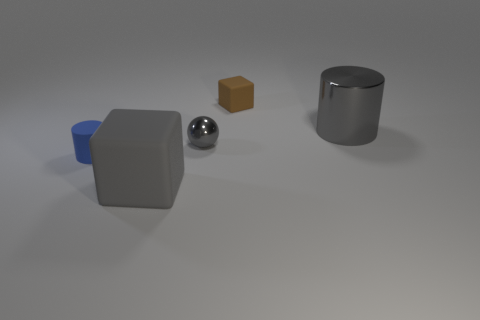There is a thing on the right side of the rubber block behind the big gray shiny object; is there a small cylinder in front of it?
Keep it short and to the point. Yes. There is a gray object that is to the left of the large metal object and behind the large gray rubber object; how big is it?
Your answer should be very brief. Small. What number of other gray cylinders have the same material as the gray cylinder?
Offer a terse response. 0. What number of cubes are tiny matte things or tiny objects?
Your answer should be very brief. 1. Is the number of matte things the same as the number of matte cylinders?
Keep it short and to the point. No. How big is the cylinder that is to the left of the small brown block that is to the right of the small matte object left of the small shiny ball?
Provide a short and direct response. Small. What color is the object that is both on the left side of the brown matte cube and right of the gray block?
Your response must be concise. Gray. There is a brown matte thing; does it have the same size as the cylinder that is right of the gray rubber object?
Provide a succinct answer. No. Is there anything else that is the same shape as the small blue rubber thing?
Ensure brevity in your answer.  Yes. What is the color of the other large rubber thing that is the same shape as the brown matte object?
Provide a succinct answer. Gray. 